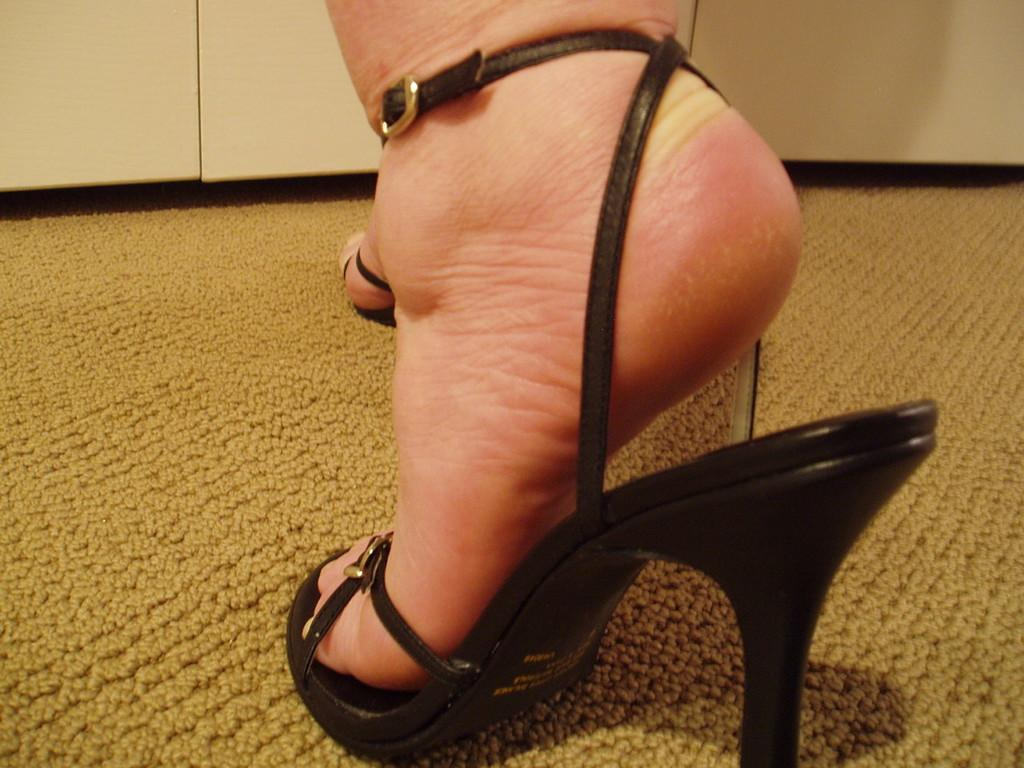What part of a person can be seen in the image? There are feet of a person in the image. What type of footwear is the person wearing? The person is wearing black heels. What can be seen in the background of the image? There are white cupboards in the background of the image. What type of ship can be seen in the image? There is no ship present in the image. 